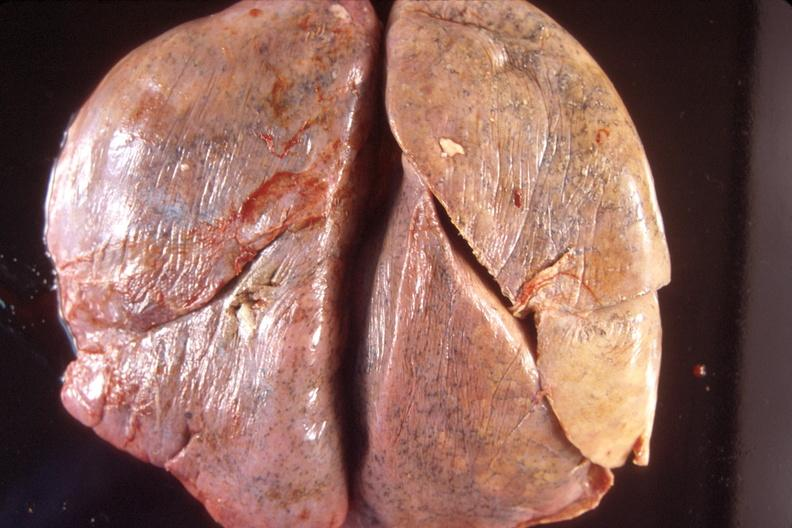where is this?
Answer the question using a single word or phrase. Lung 